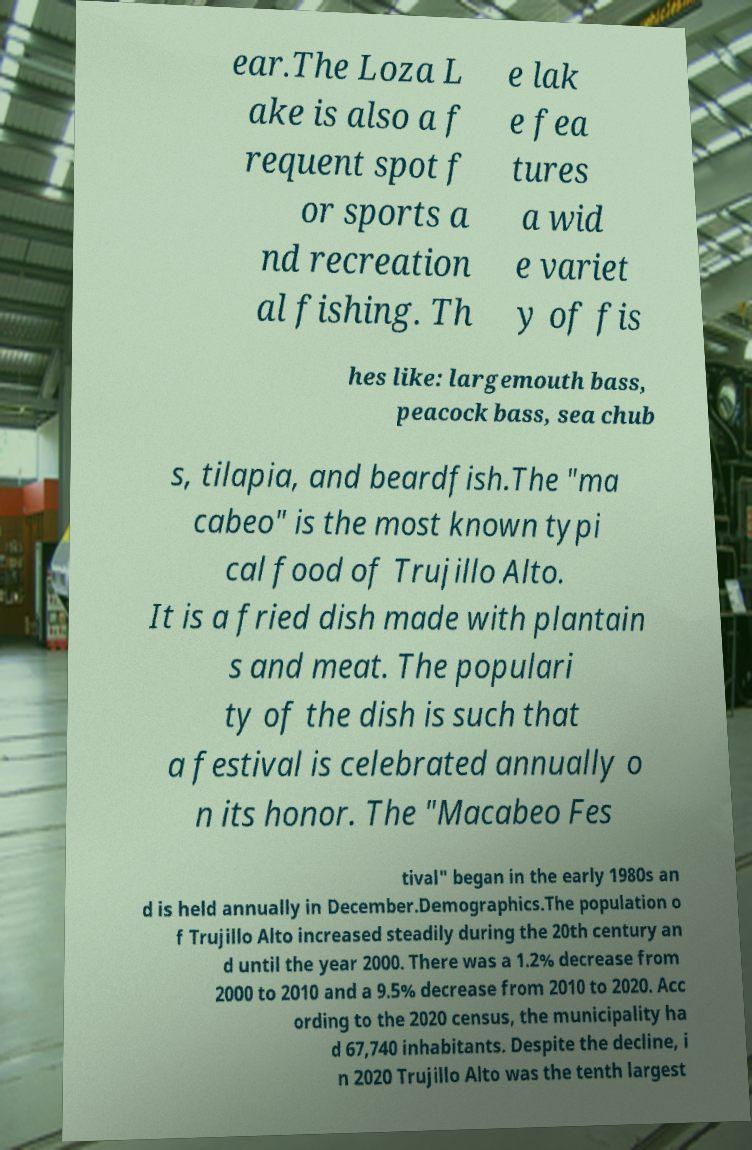Could you extract and type out the text from this image? ear.The Loza L ake is also a f requent spot f or sports a nd recreation al fishing. Th e lak e fea tures a wid e variet y of fis hes like: largemouth bass, peacock bass, sea chub s, tilapia, and beardfish.The "ma cabeo" is the most known typi cal food of Trujillo Alto. It is a fried dish made with plantain s and meat. The populari ty of the dish is such that a festival is celebrated annually o n its honor. The "Macabeo Fes tival" began in the early 1980s an d is held annually in December.Demographics.The population o f Trujillo Alto increased steadily during the 20th century an d until the year 2000. There was a 1.2% decrease from 2000 to 2010 and a 9.5% decrease from 2010 to 2020. Acc ording to the 2020 census, the municipality ha d 67,740 inhabitants. Despite the decline, i n 2020 Trujillo Alto was the tenth largest 